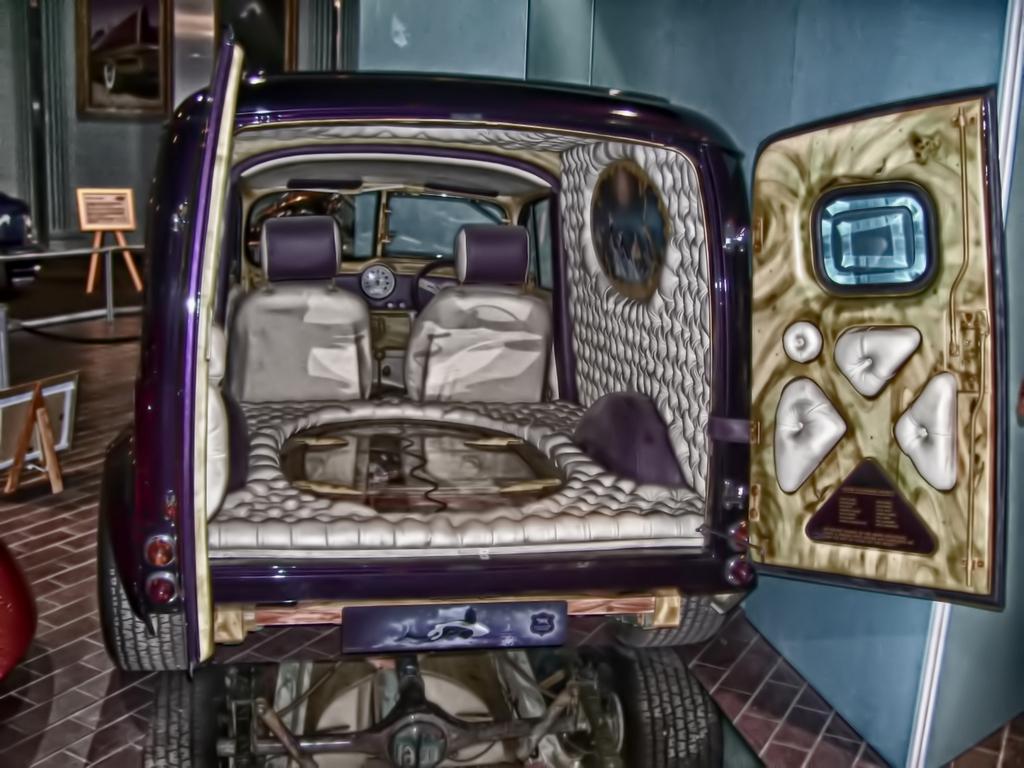How would you summarize this image in a sentence or two? In this image we can see a purple color vehicle with doors open and there is a wall with two photo frames. 